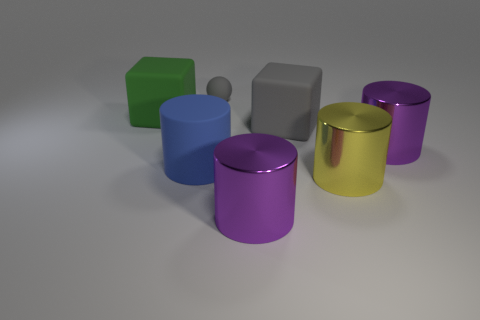Add 3 tiny balls. How many objects exist? 10 Subtract all balls. How many objects are left? 6 Subtract all big purple cylinders. Subtract all purple things. How many objects are left? 3 Add 6 big green objects. How many big green objects are left? 7 Add 4 large blue rubber objects. How many large blue rubber objects exist? 5 Subtract 0 yellow blocks. How many objects are left? 7 